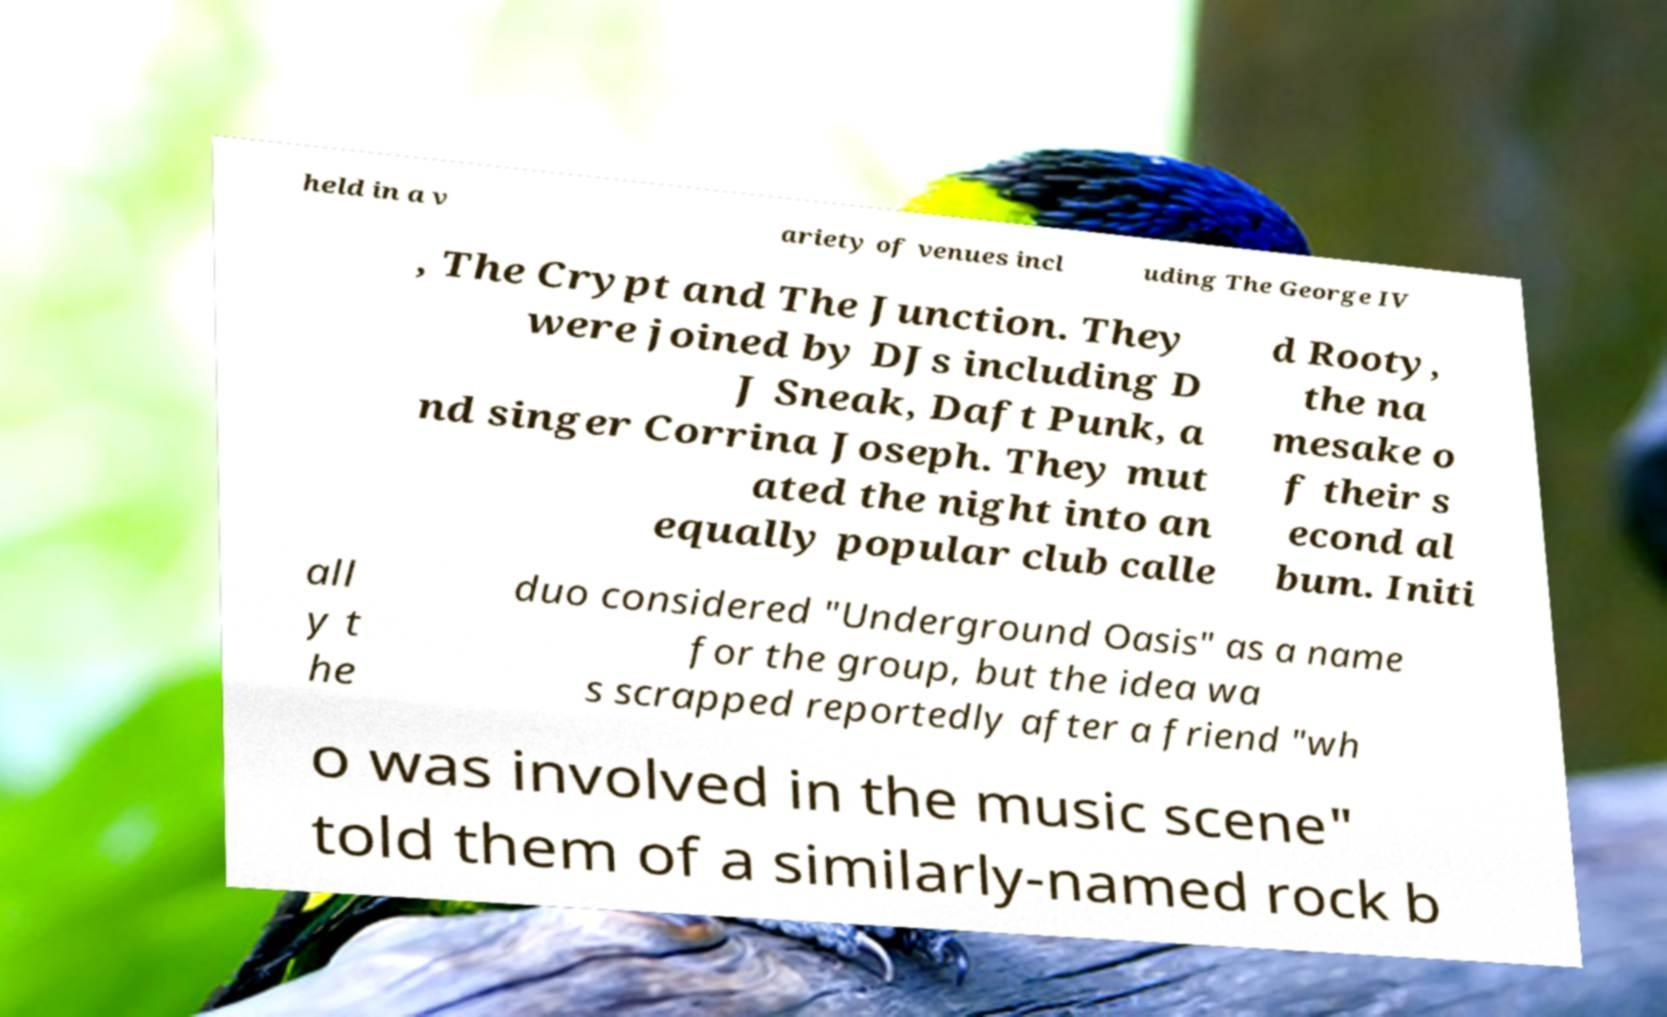Could you extract and type out the text from this image? held in a v ariety of venues incl uding The George IV , The Crypt and The Junction. They were joined by DJs including D J Sneak, Daft Punk, a nd singer Corrina Joseph. They mut ated the night into an equally popular club calle d Rooty, the na mesake o f their s econd al bum. Initi all y t he duo considered "Underground Oasis" as a name for the group, but the idea wa s scrapped reportedly after a friend "wh o was involved in the music scene" told them of a similarly-named rock b 